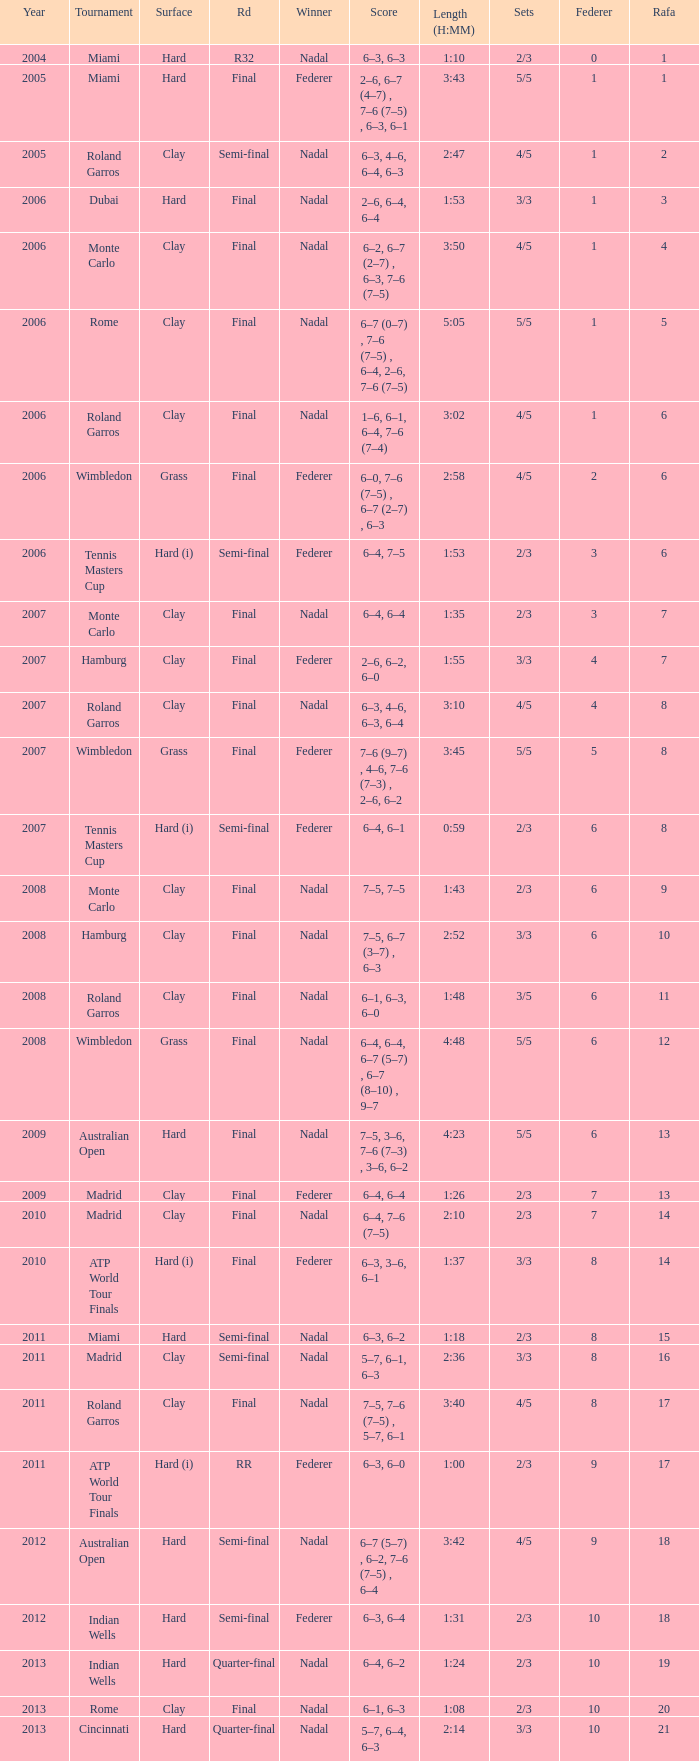What tournament did Nadal win and had a nadal of 16? Madrid. 